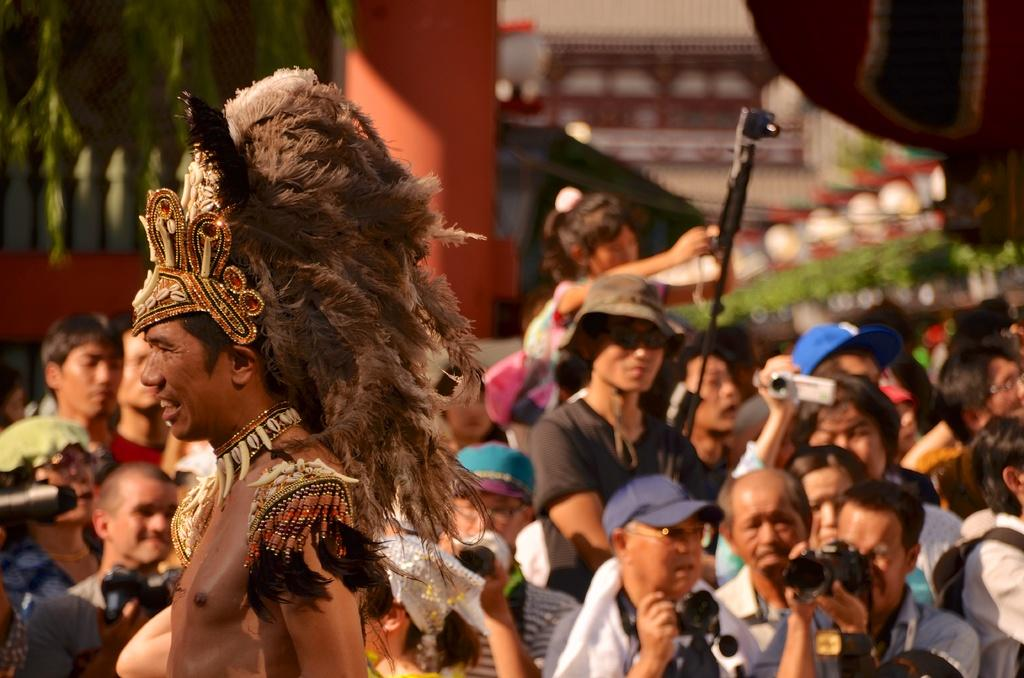What is happening in the image? There are people in the image, and they are standing. What are the people holding in the image? The people are holding cameras. Can you describe the background of the image? The background of the image is blurred. What type of love can be seen between the people in the image? There is no indication of love or any emotional connection between the people in the image, as they are simply standing and holding cameras. 